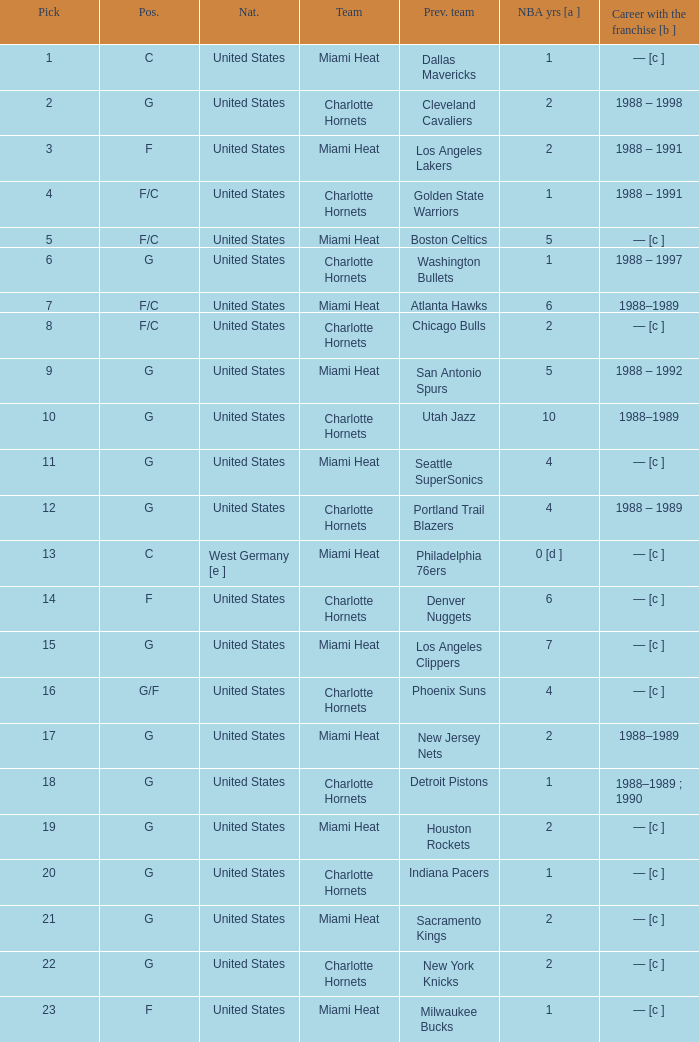What is the previous team of the player with 4 NBA years and a pick less than 16? Seattle SuperSonics, Portland Trail Blazers. 